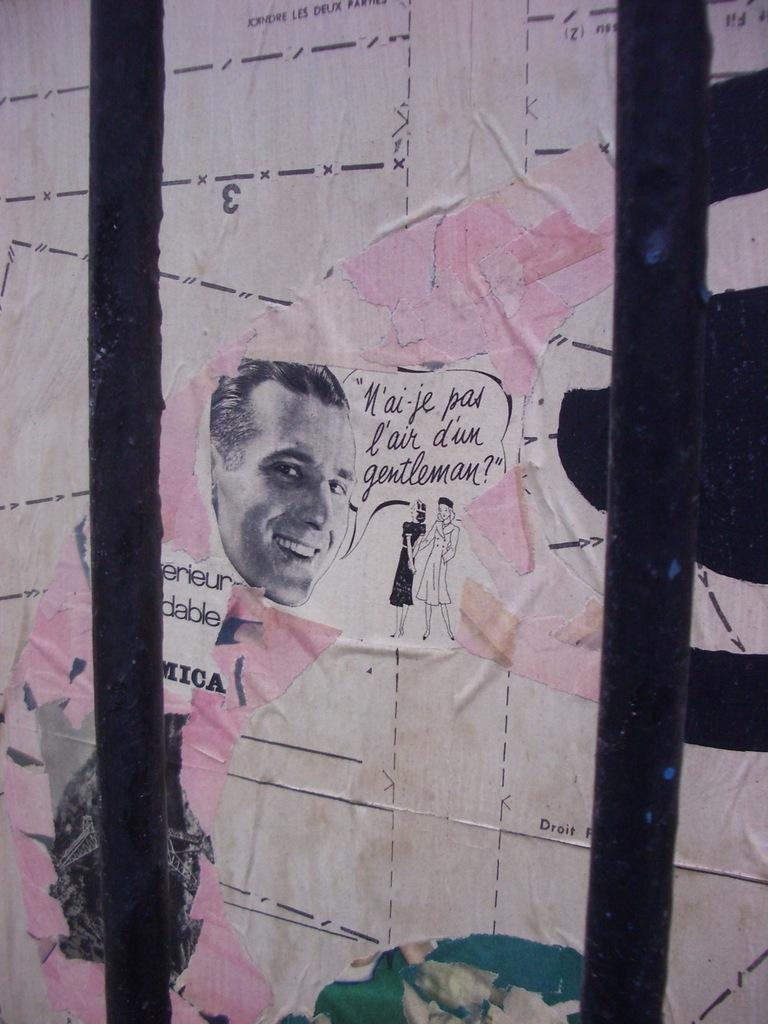How many poles are visible in the image? There are two poles in the image. What else can be seen on the wall in the image? There is a picture of a person on the wall in the image. How does the addition of a window change the image? There is no mention of a window in the provided facts, so we cannot answer a question about its addition. 